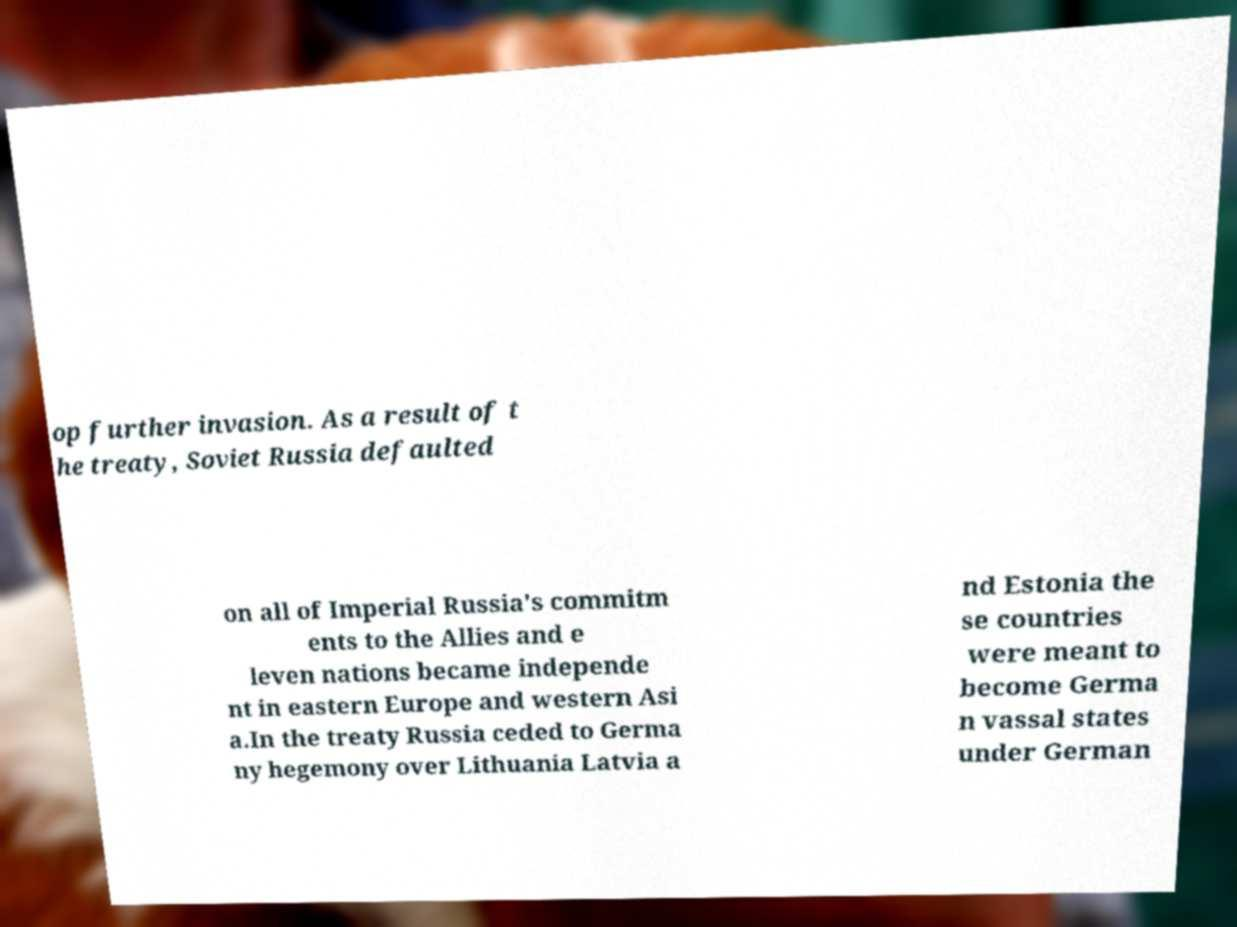Could you extract and type out the text from this image? op further invasion. As a result of t he treaty, Soviet Russia defaulted on all of Imperial Russia's commitm ents to the Allies and e leven nations became independe nt in eastern Europe and western Asi a.In the treaty Russia ceded to Germa ny hegemony over Lithuania Latvia a nd Estonia the se countries were meant to become Germa n vassal states under German 